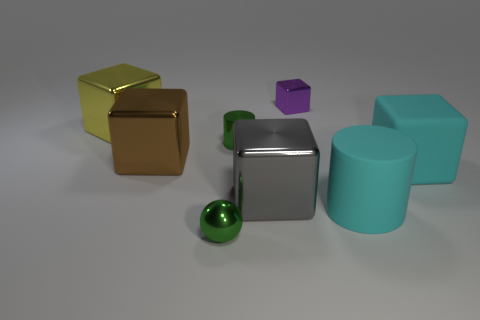What number of other things are the same color as the large matte cylinder?
Your response must be concise. 1. What number of objects are cylinders on the right side of the tiny cube or big gray cubes?
Your answer should be compact. 2. Do the metallic sphere and the rubber object that is behind the cyan cylinder have the same color?
Your response must be concise. No. Is there anything else that has the same size as the sphere?
Ensure brevity in your answer.  Yes. How big is the object that is in front of the cyan object in front of the big gray shiny thing?
Provide a short and direct response. Small. How many things are either metal cylinders or cylinders that are on the left side of the small purple metallic cube?
Provide a short and direct response. 1. Do the metal object that is in front of the gray object and the tiny purple metal object have the same shape?
Your answer should be compact. No. There is a cylinder right of the metallic block that is in front of the rubber cube; how many small purple metallic objects are on the left side of it?
Your answer should be compact. 1. Is there any other thing that has the same shape as the yellow thing?
Offer a very short reply. Yes. What number of objects are either tiny gray rubber objects or green objects?
Offer a very short reply. 2. 